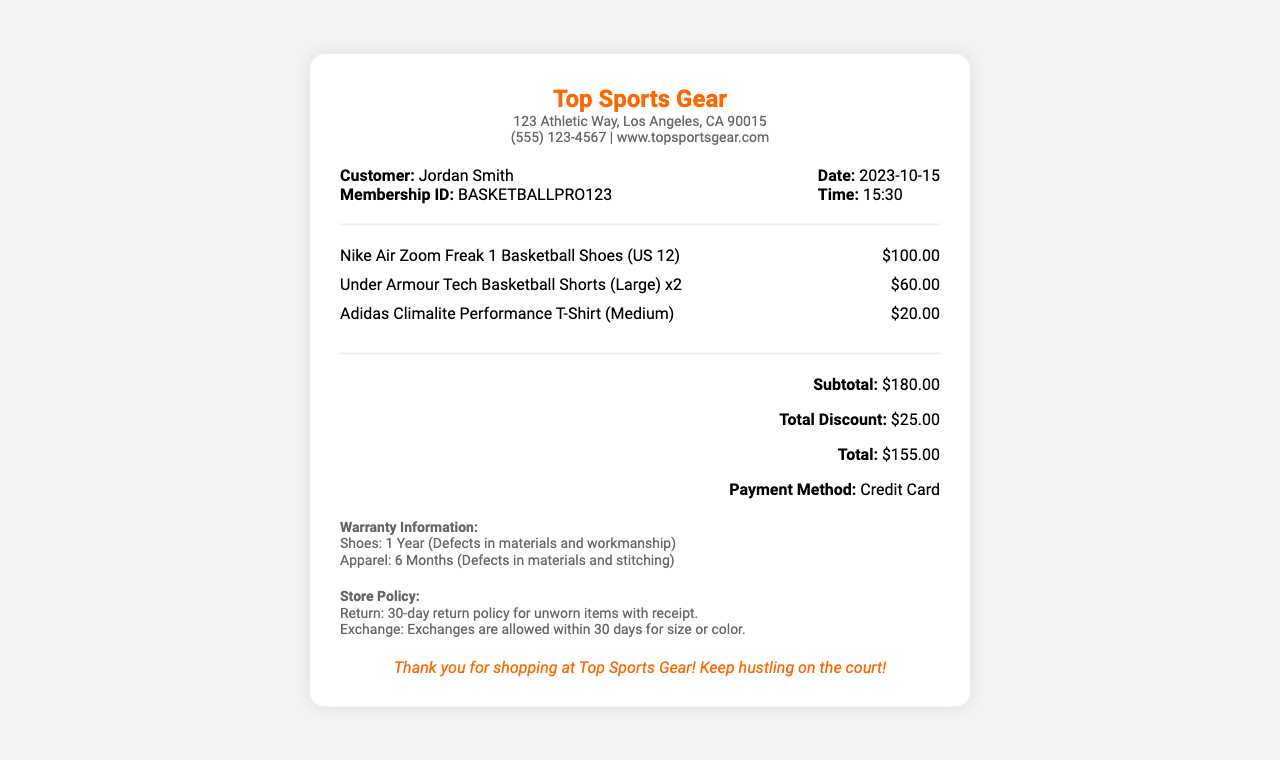What is the total amount paid for the items? The total amount paid is explicitly stated under "Total." It is calculated after applying the total discount to the subtotal.
Answer: $155.00 What is the date of the purchase? The date of the purchase can be found in the customer information section, which provides the purchase details.
Answer: 2023-10-15 What is the warranty duration for the shoes? The warranty information section indicates the duration of warranty coverage specifically for the shoes.
Answer: 1 Year How many pairs of shorts were purchased? The item description for shorts mentions the quantity purchased directly in the list of items.
Answer: 2 What is the subtotal before any discounts? The subtotal is provided directly in the totals section of the document.
Answer: $180.00 What is the name of the customer? The customer's name is clearly specified in the customer information section of the receipt.
Answer: Jordan Smith What is the store's return policy duration? The store policy section mentions the return duration for unworn items with a receipt.
Answer: 30-day What payment method was used? The payment method is indicated in the totals section of the receipt, providing relevant transaction information.
Answer: Credit Card What type of items are covered under the 6-month warranty? The warranty information specifies the items with their respective warranty periods.
Answer: Apparel 